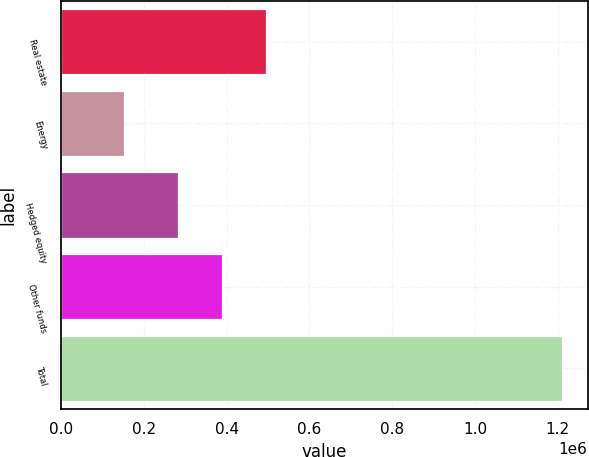Convert chart. <chart><loc_0><loc_0><loc_500><loc_500><bar_chart><fcel>Real estate<fcel>Energy<fcel>Hedged equity<fcel>Other funds<fcel>Total<nl><fcel>494204<fcel>152056<fcel>282335<fcel>388270<fcel>1.2114e+06<nl></chart> 